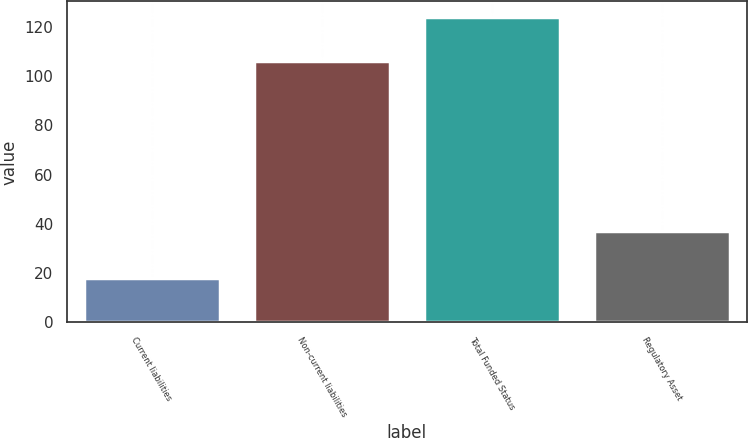<chart> <loc_0><loc_0><loc_500><loc_500><bar_chart><fcel>Current liabilities<fcel>Non-current liabilities<fcel>Total Funded Status<fcel>Regulatory Asset<nl><fcel>18<fcel>106<fcel>124<fcel>37<nl></chart> 